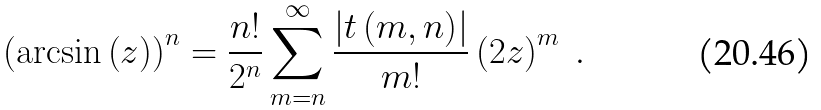<formula> <loc_0><loc_0><loc_500><loc_500>\left ( \arcsin \left ( z \right ) \right ) ^ { n } = \frac { n ! } { 2 ^ { n } } \sum _ { m = n } ^ { \infty } \frac { \left | t \left ( m , n \right ) \right | } { m ! } \left ( 2 z \right ) ^ { m } \ .</formula> 